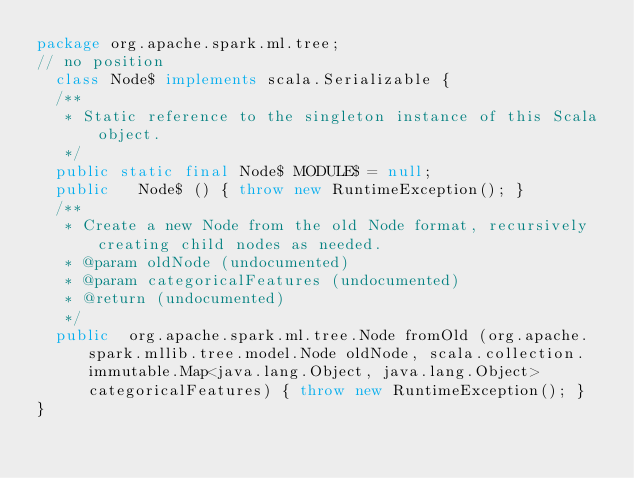<code> <loc_0><loc_0><loc_500><loc_500><_Java_>package org.apache.spark.ml.tree;
// no position
  class Node$ implements scala.Serializable {
  /**
   * Static reference to the singleton instance of this Scala object.
   */
  public static final Node$ MODULE$ = null;
  public   Node$ () { throw new RuntimeException(); }
  /**
   * Create a new Node from the old Node format, recursively creating child nodes as needed.
   * @param oldNode (undocumented)
   * @param categoricalFeatures (undocumented)
   * @return (undocumented)
   */
  public  org.apache.spark.ml.tree.Node fromOld (org.apache.spark.mllib.tree.model.Node oldNode, scala.collection.immutable.Map<java.lang.Object, java.lang.Object> categoricalFeatures) { throw new RuntimeException(); }
}
</code> 